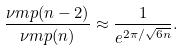Convert formula to latex. <formula><loc_0><loc_0><loc_500><loc_500>\frac { \nu m p ( n - 2 ) } { \nu m p ( n ) } \approx \frac { 1 } { e ^ { 2 \pi / \sqrt { 6 n } } } .</formula> 